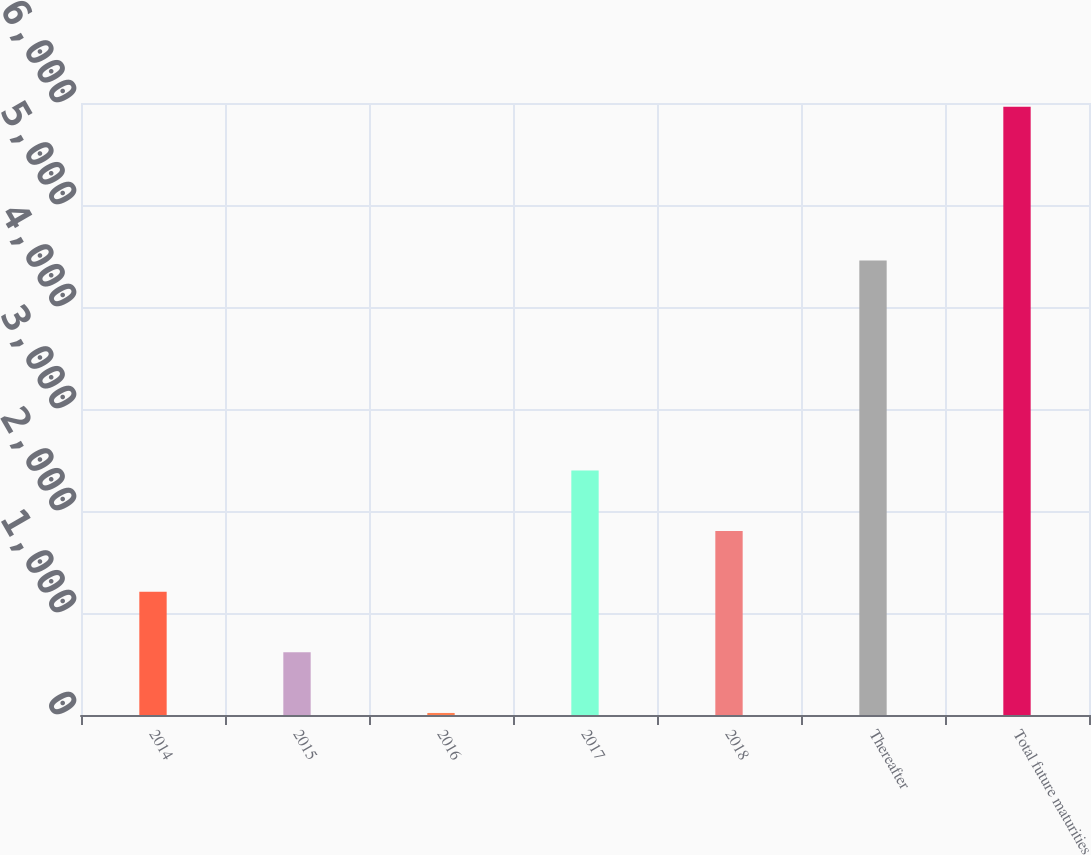Convert chart to OTSL. <chart><loc_0><loc_0><loc_500><loc_500><bar_chart><fcel>2014<fcel>2015<fcel>2016<fcel>2017<fcel>2018<fcel>Thereafter<fcel>Total future maturities<nl><fcel>1208.8<fcel>614.4<fcel>20<fcel>2397.6<fcel>1803.2<fcel>4457<fcel>5964<nl></chart> 